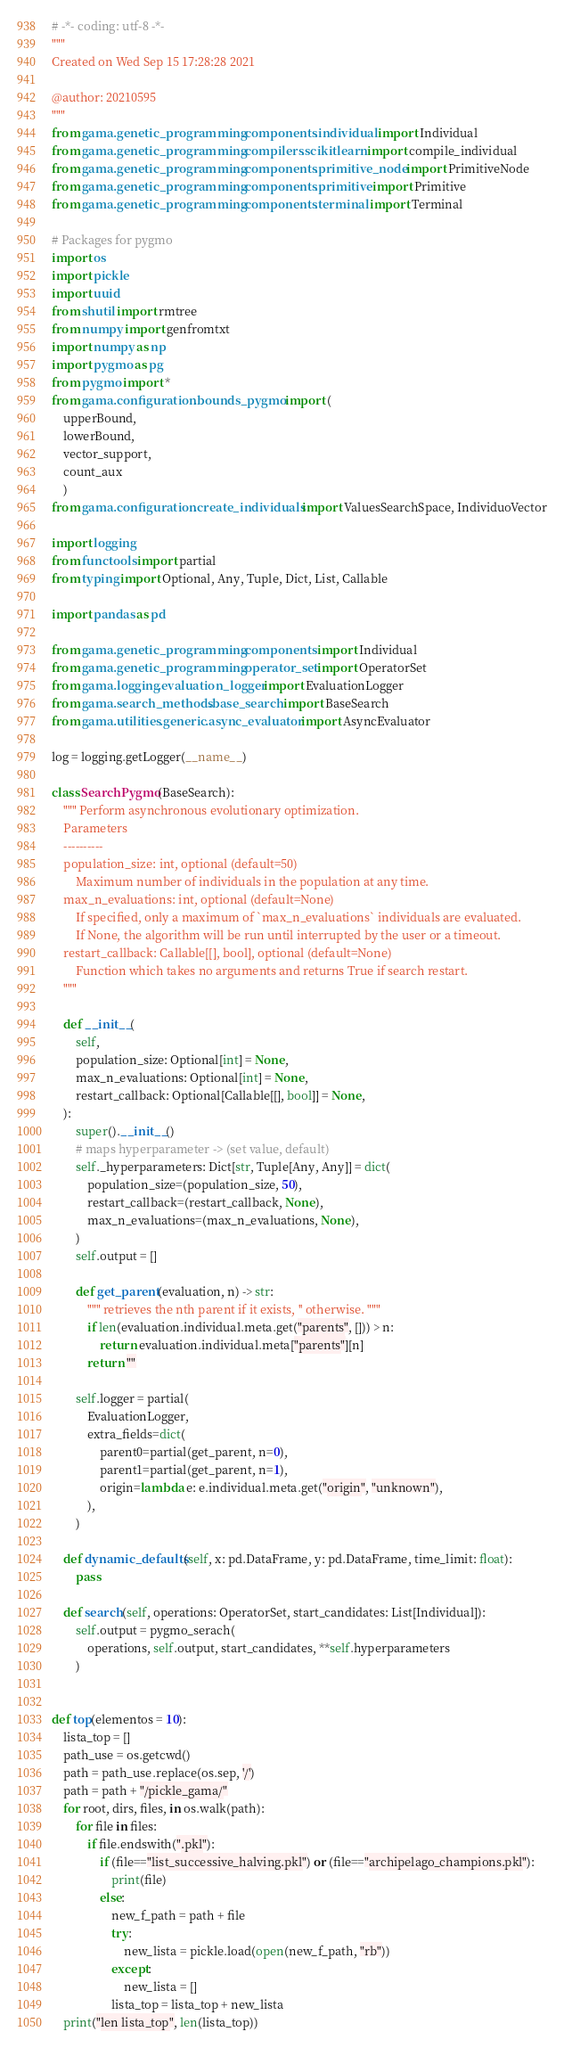<code> <loc_0><loc_0><loc_500><loc_500><_Python_># -*- coding: utf-8 -*-
"""
Created on Wed Sep 15 17:28:28 2021

@author: 20210595
"""
from gama.genetic_programming.components.individual import Individual
from gama.genetic_programming.compilers.scikitlearn import compile_individual
from gama.genetic_programming.components.primitive_node import PrimitiveNode
from gama.genetic_programming.components.primitive import Primitive
from gama.genetic_programming.components.terminal import Terminal

# Packages for pygmo
import os
import pickle
import uuid
from shutil import rmtree
from numpy import genfromtxt
import numpy as np
import pygmo as pg
from pygmo import *
from gama.configuration.bounds_pygmo import (
    upperBound, 
    lowerBound, 
    vector_support,
    count_aux
    ) 
from gama.configuration.create_individuals import ValuesSearchSpace, IndividuoVector

import logging
from functools import partial
from typing import Optional, Any, Tuple, Dict, List, Callable

import pandas as pd

from gama.genetic_programming.components import Individual
from gama.genetic_programming.operator_set import OperatorSet
from gama.logging.evaluation_logger import EvaluationLogger
from gama.search_methods.base_search import BaseSearch
from gama.utilities.generic.async_evaluator import AsyncEvaluator

log = logging.getLogger(__name__)
    
class SearchPygmo(BaseSearch):
    """ Perform asynchronous evolutionary optimization.
    Parameters
    ----------
    population_size: int, optional (default=50)
        Maximum number of individuals in the population at any time.
    max_n_evaluations: int, optional (default=None)
        If specified, only a maximum of `max_n_evaluations` individuals are evaluated.
        If None, the algorithm will be run until interrupted by the user or a timeout.
    restart_callback: Callable[[], bool], optional (default=None)
        Function which takes no arguments and returns True if search restart.
    """

    def __init__(
        self,
        population_size: Optional[int] = None,
        max_n_evaluations: Optional[int] = None,
        restart_callback: Optional[Callable[[], bool]] = None,
    ):
        super().__init__()
        # maps hyperparameter -> (set value, default)
        self._hyperparameters: Dict[str, Tuple[Any, Any]] = dict(
            population_size=(population_size, 50),
            restart_callback=(restart_callback, None),
            max_n_evaluations=(max_n_evaluations, None),
        )
        self.output = []

        def get_parent(evaluation, n) -> str:
            """ retrieves the nth parent if it exists, '' otherwise. """
            if len(evaluation.individual.meta.get("parents", [])) > n:
                return evaluation.individual.meta["parents"][n]
            return ""

        self.logger = partial(
            EvaluationLogger,
            extra_fields=dict(
                parent0=partial(get_parent, n=0),
                parent1=partial(get_parent, n=1),
                origin=lambda e: e.individual.meta.get("origin", "unknown"),
            ),
        )

    def dynamic_defaults(self, x: pd.DataFrame, y: pd.DataFrame, time_limit: float):
        pass

    def search(self, operations: OperatorSet, start_candidates: List[Individual]):
        self.output = pygmo_serach(
            operations, self.output, start_candidates, **self.hyperparameters
        ) 

   
def top(elementos = 10):
    lista_top = []
    path_use = os.getcwd()
    path = path_use.replace(os.sep, '/')
    path = path + "/pickle_gama/"
    for root, dirs, files, in os.walk(path):
        for file in files:
            if file.endswith(".pkl"):
                if (file=="list_successive_halving.pkl") or (file=="archipelago_champions.pkl"):
                    print(file)
                else:
                    new_f_path = path + file                
                    try:
                        new_lista = pickle.load(open(new_f_path, "rb"))
                    except:
                        new_lista = []
                    lista_top = lista_top + new_lista
    print("len lista_top", len(lista_top))</code> 